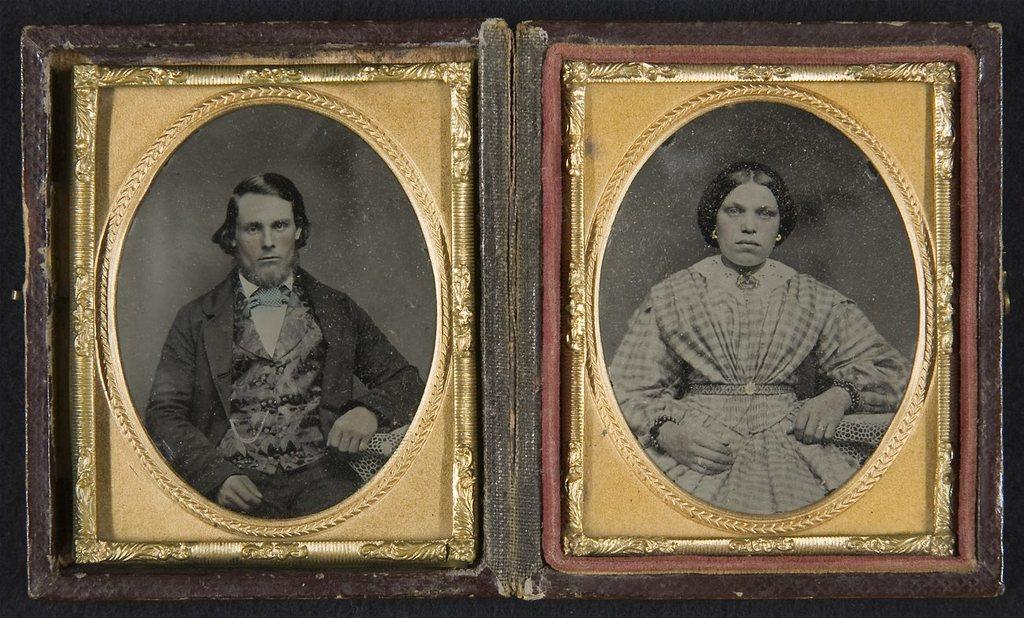What objects are present in the image? There are photo frames in the image. Where are the photo frames located? The photo frames are on a surface. What type of caption is written on the photo frames in the image? There is no caption written on the photo frames in the image. Are there any pests visible in the image? There are no pests present in the image. 